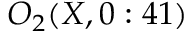Convert formula to latex. <formula><loc_0><loc_0><loc_500><loc_500>O _ { 2 } ( X , 0 \colon 4 1 )</formula> 